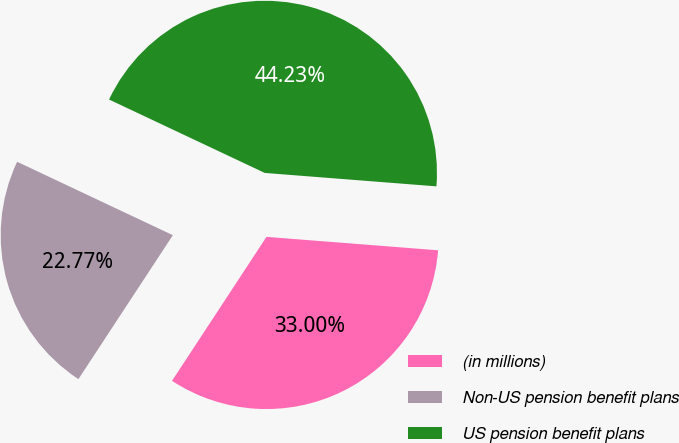Convert chart. <chart><loc_0><loc_0><loc_500><loc_500><pie_chart><fcel>(in millions)<fcel>Non-US pension benefit plans<fcel>US pension benefit plans<nl><fcel>33.0%<fcel>22.77%<fcel>44.23%<nl></chart> 